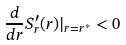<formula> <loc_0><loc_0><loc_500><loc_500>\frac { d } { d r } S _ { r } ^ { \prime } ( r ) | _ { r = r ^ { * } } < 0</formula> 